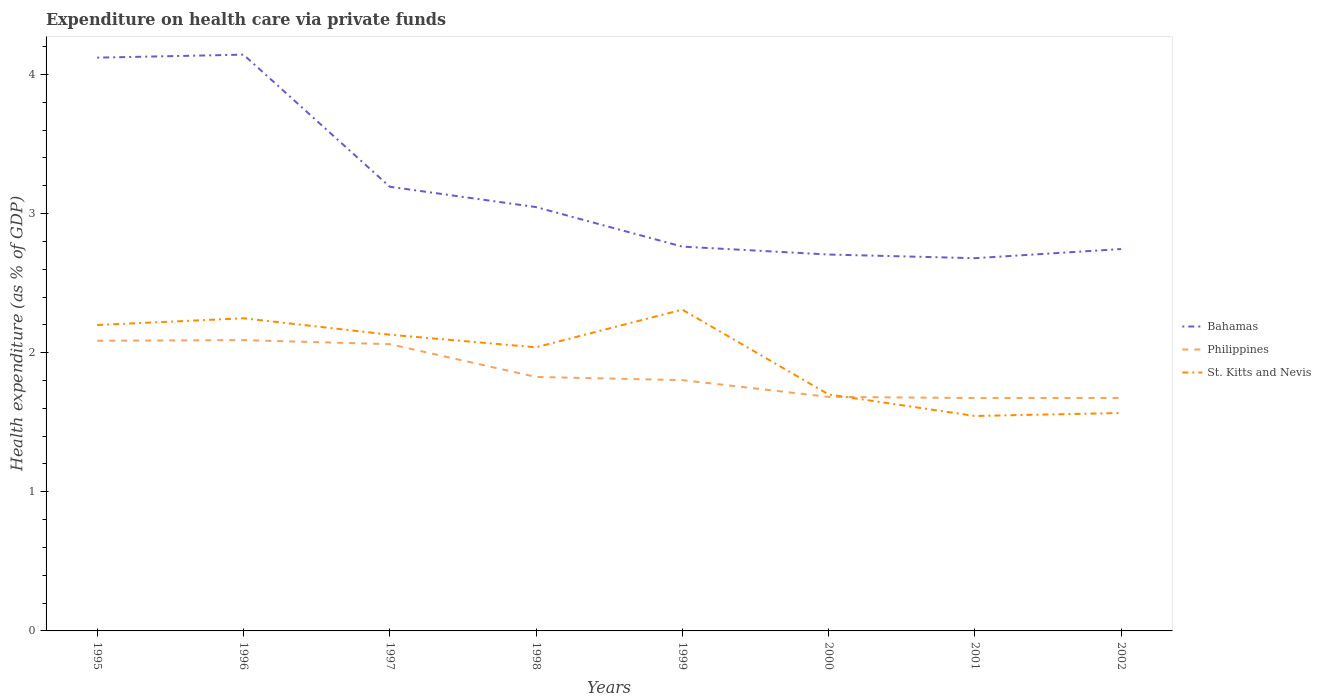How many different coloured lines are there?
Provide a short and direct response. 3. Across all years, what is the maximum expenditure made on health care in Philippines?
Provide a short and direct response. 1.67. What is the total expenditure made on health care in St. Kitts and Nevis in the graph?
Offer a very short reply. 0.43. What is the difference between the highest and the second highest expenditure made on health care in Bahamas?
Give a very brief answer. 1.46. What is the difference between the highest and the lowest expenditure made on health care in Philippines?
Ensure brevity in your answer.  3. Is the expenditure made on health care in St. Kitts and Nevis strictly greater than the expenditure made on health care in Bahamas over the years?
Offer a very short reply. Yes. How many lines are there?
Give a very brief answer. 3. What is the difference between two consecutive major ticks on the Y-axis?
Ensure brevity in your answer.  1. Are the values on the major ticks of Y-axis written in scientific E-notation?
Keep it short and to the point. No. Does the graph contain grids?
Your response must be concise. No. How are the legend labels stacked?
Your response must be concise. Vertical. What is the title of the graph?
Keep it short and to the point. Expenditure on health care via private funds. What is the label or title of the Y-axis?
Your answer should be compact. Health expenditure (as % of GDP). What is the Health expenditure (as % of GDP) in Bahamas in 1995?
Keep it short and to the point. 4.12. What is the Health expenditure (as % of GDP) in Philippines in 1995?
Provide a short and direct response. 2.09. What is the Health expenditure (as % of GDP) of St. Kitts and Nevis in 1995?
Offer a terse response. 2.2. What is the Health expenditure (as % of GDP) in Bahamas in 1996?
Your answer should be very brief. 4.14. What is the Health expenditure (as % of GDP) of Philippines in 1996?
Offer a very short reply. 2.09. What is the Health expenditure (as % of GDP) in St. Kitts and Nevis in 1996?
Offer a terse response. 2.25. What is the Health expenditure (as % of GDP) in Bahamas in 1997?
Provide a short and direct response. 3.19. What is the Health expenditure (as % of GDP) of Philippines in 1997?
Provide a short and direct response. 2.06. What is the Health expenditure (as % of GDP) in St. Kitts and Nevis in 1997?
Offer a very short reply. 2.13. What is the Health expenditure (as % of GDP) in Bahamas in 1998?
Your answer should be very brief. 3.05. What is the Health expenditure (as % of GDP) of Philippines in 1998?
Make the answer very short. 1.83. What is the Health expenditure (as % of GDP) of St. Kitts and Nevis in 1998?
Keep it short and to the point. 2.04. What is the Health expenditure (as % of GDP) in Bahamas in 1999?
Provide a short and direct response. 2.76. What is the Health expenditure (as % of GDP) of Philippines in 1999?
Offer a very short reply. 1.8. What is the Health expenditure (as % of GDP) in St. Kitts and Nevis in 1999?
Provide a succinct answer. 2.31. What is the Health expenditure (as % of GDP) in Bahamas in 2000?
Your answer should be compact. 2.71. What is the Health expenditure (as % of GDP) of Philippines in 2000?
Offer a very short reply. 1.68. What is the Health expenditure (as % of GDP) in St. Kitts and Nevis in 2000?
Provide a succinct answer. 1.7. What is the Health expenditure (as % of GDP) of Bahamas in 2001?
Give a very brief answer. 2.68. What is the Health expenditure (as % of GDP) of Philippines in 2001?
Make the answer very short. 1.67. What is the Health expenditure (as % of GDP) of St. Kitts and Nevis in 2001?
Your response must be concise. 1.55. What is the Health expenditure (as % of GDP) in Bahamas in 2002?
Keep it short and to the point. 2.75. What is the Health expenditure (as % of GDP) in Philippines in 2002?
Your response must be concise. 1.67. What is the Health expenditure (as % of GDP) in St. Kitts and Nevis in 2002?
Your response must be concise. 1.57. Across all years, what is the maximum Health expenditure (as % of GDP) in Bahamas?
Your response must be concise. 4.14. Across all years, what is the maximum Health expenditure (as % of GDP) of Philippines?
Your answer should be compact. 2.09. Across all years, what is the maximum Health expenditure (as % of GDP) of St. Kitts and Nevis?
Keep it short and to the point. 2.31. Across all years, what is the minimum Health expenditure (as % of GDP) in Bahamas?
Your answer should be compact. 2.68. Across all years, what is the minimum Health expenditure (as % of GDP) of Philippines?
Your response must be concise. 1.67. Across all years, what is the minimum Health expenditure (as % of GDP) of St. Kitts and Nevis?
Provide a short and direct response. 1.55. What is the total Health expenditure (as % of GDP) in Bahamas in the graph?
Your answer should be very brief. 25.39. What is the total Health expenditure (as % of GDP) in Philippines in the graph?
Keep it short and to the point. 14.9. What is the total Health expenditure (as % of GDP) of St. Kitts and Nevis in the graph?
Keep it short and to the point. 15.74. What is the difference between the Health expenditure (as % of GDP) of Bahamas in 1995 and that in 1996?
Your answer should be very brief. -0.02. What is the difference between the Health expenditure (as % of GDP) of Philippines in 1995 and that in 1996?
Your answer should be compact. -0. What is the difference between the Health expenditure (as % of GDP) in St. Kitts and Nevis in 1995 and that in 1996?
Your response must be concise. -0.05. What is the difference between the Health expenditure (as % of GDP) in Bahamas in 1995 and that in 1997?
Provide a short and direct response. 0.93. What is the difference between the Health expenditure (as % of GDP) in Philippines in 1995 and that in 1997?
Make the answer very short. 0.02. What is the difference between the Health expenditure (as % of GDP) of St. Kitts and Nevis in 1995 and that in 1997?
Provide a succinct answer. 0.07. What is the difference between the Health expenditure (as % of GDP) in Bahamas in 1995 and that in 1998?
Ensure brevity in your answer.  1.07. What is the difference between the Health expenditure (as % of GDP) in Philippines in 1995 and that in 1998?
Ensure brevity in your answer.  0.26. What is the difference between the Health expenditure (as % of GDP) in St. Kitts and Nevis in 1995 and that in 1998?
Provide a short and direct response. 0.16. What is the difference between the Health expenditure (as % of GDP) in Bahamas in 1995 and that in 1999?
Your answer should be compact. 1.36. What is the difference between the Health expenditure (as % of GDP) of Philippines in 1995 and that in 1999?
Provide a succinct answer. 0.28. What is the difference between the Health expenditure (as % of GDP) in St. Kitts and Nevis in 1995 and that in 1999?
Give a very brief answer. -0.11. What is the difference between the Health expenditure (as % of GDP) in Bahamas in 1995 and that in 2000?
Make the answer very short. 1.42. What is the difference between the Health expenditure (as % of GDP) of Philippines in 1995 and that in 2000?
Make the answer very short. 0.4. What is the difference between the Health expenditure (as % of GDP) in St. Kitts and Nevis in 1995 and that in 2000?
Your response must be concise. 0.5. What is the difference between the Health expenditure (as % of GDP) in Bahamas in 1995 and that in 2001?
Give a very brief answer. 1.44. What is the difference between the Health expenditure (as % of GDP) in Philippines in 1995 and that in 2001?
Your answer should be compact. 0.41. What is the difference between the Health expenditure (as % of GDP) of St. Kitts and Nevis in 1995 and that in 2001?
Give a very brief answer. 0.65. What is the difference between the Health expenditure (as % of GDP) of Bahamas in 1995 and that in 2002?
Keep it short and to the point. 1.38. What is the difference between the Health expenditure (as % of GDP) in Philippines in 1995 and that in 2002?
Provide a succinct answer. 0.41. What is the difference between the Health expenditure (as % of GDP) in St. Kitts and Nevis in 1995 and that in 2002?
Provide a short and direct response. 0.63. What is the difference between the Health expenditure (as % of GDP) of Bahamas in 1996 and that in 1997?
Ensure brevity in your answer.  0.95. What is the difference between the Health expenditure (as % of GDP) in Philippines in 1996 and that in 1997?
Your response must be concise. 0.03. What is the difference between the Health expenditure (as % of GDP) of St. Kitts and Nevis in 1996 and that in 1997?
Provide a short and direct response. 0.12. What is the difference between the Health expenditure (as % of GDP) in Bahamas in 1996 and that in 1998?
Give a very brief answer. 1.1. What is the difference between the Health expenditure (as % of GDP) of Philippines in 1996 and that in 1998?
Make the answer very short. 0.26. What is the difference between the Health expenditure (as % of GDP) of St. Kitts and Nevis in 1996 and that in 1998?
Provide a succinct answer. 0.21. What is the difference between the Health expenditure (as % of GDP) of Bahamas in 1996 and that in 1999?
Provide a succinct answer. 1.38. What is the difference between the Health expenditure (as % of GDP) of Philippines in 1996 and that in 1999?
Give a very brief answer. 0.29. What is the difference between the Health expenditure (as % of GDP) in St. Kitts and Nevis in 1996 and that in 1999?
Keep it short and to the point. -0.06. What is the difference between the Health expenditure (as % of GDP) of Bahamas in 1996 and that in 2000?
Offer a terse response. 1.44. What is the difference between the Health expenditure (as % of GDP) in Philippines in 1996 and that in 2000?
Your response must be concise. 0.41. What is the difference between the Health expenditure (as % of GDP) of St. Kitts and Nevis in 1996 and that in 2000?
Offer a terse response. 0.55. What is the difference between the Health expenditure (as % of GDP) in Bahamas in 1996 and that in 2001?
Provide a short and direct response. 1.46. What is the difference between the Health expenditure (as % of GDP) in Philippines in 1996 and that in 2001?
Offer a very short reply. 0.42. What is the difference between the Health expenditure (as % of GDP) in St. Kitts and Nevis in 1996 and that in 2001?
Make the answer very short. 0.7. What is the difference between the Health expenditure (as % of GDP) in Bahamas in 1996 and that in 2002?
Provide a short and direct response. 1.4. What is the difference between the Health expenditure (as % of GDP) of Philippines in 1996 and that in 2002?
Keep it short and to the point. 0.42. What is the difference between the Health expenditure (as % of GDP) in St. Kitts and Nevis in 1996 and that in 2002?
Ensure brevity in your answer.  0.68. What is the difference between the Health expenditure (as % of GDP) in Bahamas in 1997 and that in 1998?
Offer a terse response. 0.15. What is the difference between the Health expenditure (as % of GDP) in Philippines in 1997 and that in 1998?
Your answer should be very brief. 0.24. What is the difference between the Health expenditure (as % of GDP) in St. Kitts and Nevis in 1997 and that in 1998?
Your answer should be very brief. 0.09. What is the difference between the Health expenditure (as % of GDP) of Bahamas in 1997 and that in 1999?
Provide a short and direct response. 0.43. What is the difference between the Health expenditure (as % of GDP) in Philippines in 1997 and that in 1999?
Your answer should be compact. 0.26. What is the difference between the Health expenditure (as % of GDP) of St. Kitts and Nevis in 1997 and that in 1999?
Give a very brief answer. -0.18. What is the difference between the Health expenditure (as % of GDP) in Bahamas in 1997 and that in 2000?
Make the answer very short. 0.49. What is the difference between the Health expenditure (as % of GDP) of Philippines in 1997 and that in 2000?
Ensure brevity in your answer.  0.38. What is the difference between the Health expenditure (as % of GDP) in St. Kitts and Nevis in 1997 and that in 2000?
Make the answer very short. 0.43. What is the difference between the Health expenditure (as % of GDP) in Bahamas in 1997 and that in 2001?
Make the answer very short. 0.51. What is the difference between the Health expenditure (as % of GDP) of Philippines in 1997 and that in 2001?
Provide a succinct answer. 0.39. What is the difference between the Health expenditure (as % of GDP) in St. Kitts and Nevis in 1997 and that in 2001?
Your response must be concise. 0.58. What is the difference between the Health expenditure (as % of GDP) of Bahamas in 1997 and that in 2002?
Your answer should be compact. 0.45. What is the difference between the Health expenditure (as % of GDP) of Philippines in 1997 and that in 2002?
Provide a succinct answer. 0.39. What is the difference between the Health expenditure (as % of GDP) in St. Kitts and Nevis in 1997 and that in 2002?
Offer a very short reply. 0.56. What is the difference between the Health expenditure (as % of GDP) of Bahamas in 1998 and that in 1999?
Your answer should be very brief. 0.28. What is the difference between the Health expenditure (as % of GDP) in Philippines in 1998 and that in 1999?
Ensure brevity in your answer.  0.02. What is the difference between the Health expenditure (as % of GDP) in St. Kitts and Nevis in 1998 and that in 1999?
Your response must be concise. -0.27. What is the difference between the Health expenditure (as % of GDP) of Bahamas in 1998 and that in 2000?
Your answer should be very brief. 0.34. What is the difference between the Health expenditure (as % of GDP) in Philippines in 1998 and that in 2000?
Provide a succinct answer. 0.14. What is the difference between the Health expenditure (as % of GDP) of St. Kitts and Nevis in 1998 and that in 2000?
Your answer should be compact. 0.34. What is the difference between the Health expenditure (as % of GDP) of Bahamas in 1998 and that in 2001?
Your response must be concise. 0.37. What is the difference between the Health expenditure (as % of GDP) in Philippines in 1998 and that in 2001?
Provide a succinct answer. 0.15. What is the difference between the Health expenditure (as % of GDP) in St. Kitts and Nevis in 1998 and that in 2001?
Keep it short and to the point. 0.49. What is the difference between the Health expenditure (as % of GDP) of Bahamas in 1998 and that in 2002?
Provide a succinct answer. 0.3. What is the difference between the Health expenditure (as % of GDP) of Philippines in 1998 and that in 2002?
Ensure brevity in your answer.  0.15. What is the difference between the Health expenditure (as % of GDP) in St. Kitts and Nevis in 1998 and that in 2002?
Keep it short and to the point. 0.47. What is the difference between the Health expenditure (as % of GDP) in Bahamas in 1999 and that in 2000?
Make the answer very short. 0.06. What is the difference between the Health expenditure (as % of GDP) of Philippines in 1999 and that in 2000?
Offer a terse response. 0.12. What is the difference between the Health expenditure (as % of GDP) of St. Kitts and Nevis in 1999 and that in 2000?
Provide a short and direct response. 0.61. What is the difference between the Health expenditure (as % of GDP) in Bahamas in 1999 and that in 2001?
Offer a very short reply. 0.08. What is the difference between the Health expenditure (as % of GDP) in Philippines in 1999 and that in 2001?
Provide a succinct answer. 0.13. What is the difference between the Health expenditure (as % of GDP) of St. Kitts and Nevis in 1999 and that in 2001?
Your answer should be compact. 0.76. What is the difference between the Health expenditure (as % of GDP) in Bahamas in 1999 and that in 2002?
Your response must be concise. 0.02. What is the difference between the Health expenditure (as % of GDP) in Philippines in 1999 and that in 2002?
Make the answer very short. 0.13. What is the difference between the Health expenditure (as % of GDP) of St. Kitts and Nevis in 1999 and that in 2002?
Provide a short and direct response. 0.74. What is the difference between the Health expenditure (as % of GDP) in Bahamas in 2000 and that in 2001?
Provide a short and direct response. 0.03. What is the difference between the Health expenditure (as % of GDP) in Philippines in 2000 and that in 2001?
Provide a succinct answer. 0.01. What is the difference between the Health expenditure (as % of GDP) in St. Kitts and Nevis in 2000 and that in 2001?
Ensure brevity in your answer.  0.15. What is the difference between the Health expenditure (as % of GDP) of Bahamas in 2000 and that in 2002?
Your answer should be compact. -0.04. What is the difference between the Health expenditure (as % of GDP) of Philippines in 2000 and that in 2002?
Your answer should be very brief. 0.01. What is the difference between the Health expenditure (as % of GDP) in St. Kitts and Nevis in 2000 and that in 2002?
Offer a very short reply. 0.13. What is the difference between the Health expenditure (as % of GDP) of Bahamas in 2001 and that in 2002?
Ensure brevity in your answer.  -0.07. What is the difference between the Health expenditure (as % of GDP) in Philippines in 2001 and that in 2002?
Your response must be concise. -0. What is the difference between the Health expenditure (as % of GDP) in St. Kitts and Nevis in 2001 and that in 2002?
Make the answer very short. -0.02. What is the difference between the Health expenditure (as % of GDP) of Bahamas in 1995 and the Health expenditure (as % of GDP) of Philippines in 1996?
Make the answer very short. 2.03. What is the difference between the Health expenditure (as % of GDP) of Bahamas in 1995 and the Health expenditure (as % of GDP) of St. Kitts and Nevis in 1996?
Make the answer very short. 1.87. What is the difference between the Health expenditure (as % of GDP) in Philippines in 1995 and the Health expenditure (as % of GDP) in St. Kitts and Nevis in 1996?
Offer a terse response. -0.16. What is the difference between the Health expenditure (as % of GDP) in Bahamas in 1995 and the Health expenditure (as % of GDP) in Philippines in 1997?
Give a very brief answer. 2.06. What is the difference between the Health expenditure (as % of GDP) in Bahamas in 1995 and the Health expenditure (as % of GDP) in St. Kitts and Nevis in 1997?
Your answer should be compact. 1.99. What is the difference between the Health expenditure (as % of GDP) of Philippines in 1995 and the Health expenditure (as % of GDP) of St. Kitts and Nevis in 1997?
Offer a terse response. -0.04. What is the difference between the Health expenditure (as % of GDP) in Bahamas in 1995 and the Health expenditure (as % of GDP) in Philippines in 1998?
Keep it short and to the point. 2.3. What is the difference between the Health expenditure (as % of GDP) in Bahamas in 1995 and the Health expenditure (as % of GDP) in St. Kitts and Nevis in 1998?
Your answer should be compact. 2.08. What is the difference between the Health expenditure (as % of GDP) of Philippines in 1995 and the Health expenditure (as % of GDP) of St. Kitts and Nevis in 1998?
Offer a very short reply. 0.05. What is the difference between the Health expenditure (as % of GDP) in Bahamas in 1995 and the Health expenditure (as % of GDP) in Philippines in 1999?
Provide a short and direct response. 2.32. What is the difference between the Health expenditure (as % of GDP) in Bahamas in 1995 and the Health expenditure (as % of GDP) in St. Kitts and Nevis in 1999?
Give a very brief answer. 1.81. What is the difference between the Health expenditure (as % of GDP) of Philippines in 1995 and the Health expenditure (as % of GDP) of St. Kitts and Nevis in 1999?
Your response must be concise. -0.22. What is the difference between the Health expenditure (as % of GDP) in Bahamas in 1995 and the Health expenditure (as % of GDP) in Philippines in 2000?
Ensure brevity in your answer.  2.44. What is the difference between the Health expenditure (as % of GDP) of Bahamas in 1995 and the Health expenditure (as % of GDP) of St. Kitts and Nevis in 2000?
Your answer should be very brief. 2.42. What is the difference between the Health expenditure (as % of GDP) of Philippines in 1995 and the Health expenditure (as % of GDP) of St. Kitts and Nevis in 2000?
Your answer should be very brief. 0.39. What is the difference between the Health expenditure (as % of GDP) in Bahamas in 1995 and the Health expenditure (as % of GDP) in Philippines in 2001?
Your answer should be very brief. 2.45. What is the difference between the Health expenditure (as % of GDP) of Bahamas in 1995 and the Health expenditure (as % of GDP) of St. Kitts and Nevis in 2001?
Make the answer very short. 2.58. What is the difference between the Health expenditure (as % of GDP) of Philippines in 1995 and the Health expenditure (as % of GDP) of St. Kitts and Nevis in 2001?
Keep it short and to the point. 0.54. What is the difference between the Health expenditure (as % of GDP) in Bahamas in 1995 and the Health expenditure (as % of GDP) in Philippines in 2002?
Your answer should be very brief. 2.45. What is the difference between the Health expenditure (as % of GDP) in Bahamas in 1995 and the Health expenditure (as % of GDP) in St. Kitts and Nevis in 2002?
Your answer should be very brief. 2.55. What is the difference between the Health expenditure (as % of GDP) of Philippines in 1995 and the Health expenditure (as % of GDP) of St. Kitts and Nevis in 2002?
Offer a very short reply. 0.52. What is the difference between the Health expenditure (as % of GDP) in Bahamas in 1996 and the Health expenditure (as % of GDP) in Philippines in 1997?
Make the answer very short. 2.08. What is the difference between the Health expenditure (as % of GDP) in Bahamas in 1996 and the Health expenditure (as % of GDP) in St. Kitts and Nevis in 1997?
Ensure brevity in your answer.  2.01. What is the difference between the Health expenditure (as % of GDP) of Philippines in 1996 and the Health expenditure (as % of GDP) of St. Kitts and Nevis in 1997?
Offer a very short reply. -0.04. What is the difference between the Health expenditure (as % of GDP) of Bahamas in 1996 and the Health expenditure (as % of GDP) of Philippines in 1998?
Your answer should be very brief. 2.32. What is the difference between the Health expenditure (as % of GDP) in Bahamas in 1996 and the Health expenditure (as % of GDP) in St. Kitts and Nevis in 1998?
Offer a terse response. 2.1. What is the difference between the Health expenditure (as % of GDP) of Philippines in 1996 and the Health expenditure (as % of GDP) of St. Kitts and Nevis in 1998?
Keep it short and to the point. 0.05. What is the difference between the Health expenditure (as % of GDP) in Bahamas in 1996 and the Health expenditure (as % of GDP) in Philippines in 1999?
Keep it short and to the point. 2.34. What is the difference between the Health expenditure (as % of GDP) in Bahamas in 1996 and the Health expenditure (as % of GDP) in St. Kitts and Nevis in 1999?
Offer a very short reply. 1.83. What is the difference between the Health expenditure (as % of GDP) in Philippines in 1996 and the Health expenditure (as % of GDP) in St. Kitts and Nevis in 1999?
Your response must be concise. -0.22. What is the difference between the Health expenditure (as % of GDP) in Bahamas in 1996 and the Health expenditure (as % of GDP) in Philippines in 2000?
Offer a very short reply. 2.46. What is the difference between the Health expenditure (as % of GDP) in Bahamas in 1996 and the Health expenditure (as % of GDP) in St. Kitts and Nevis in 2000?
Offer a very short reply. 2.44. What is the difference between the Health expenditure (as % of GDP) of Philippines in 1996 and the Health expenditure (as % of GDP) of St. Kitts and Nevis in 2000?
Your response must be concise. 0.39. What is the difference between the Health expenditure (as % of GDP) in Bahamas in 1996 and the Health expenditure (as % of GDP) in Philippines in 2001?
Give a very brief answer. 2.47. What is the difference between the Health expenditure (as % of GDP) in Bahamas in 1996 and the Health expenditure (as % of GDP) in St. Kitts and Nevis in 2001?
Make the answer very short. 2.6. What is the difference between the Health expenditure (as % of GDP) in Philippines in 1996 and the Health expenditure (as % of GDP) in St. Kitts and Nevis in 2001?
Offer a terse response. 0.55. What is the difference between the Health expenditure (as % of GDP) in Bahamas in 1996 and the Health expenditure (as % of GDP) in Philippines in 2002?
Ensure brevity in your answer.  2.47. What is the difference between the Health expenditure (as % of GDP) in Bahamas in 1996 and the Health expenditure (as % of GDP) in St. Kitts and Nevis in 2002?
Offer a terse response. 2.58. What is the difference between the Health expenditure (as % of GDP) of Philippines in 1996 and the Health expenditure (as % of GDP) of St. Kitts and Nevis in 2002?
Keep it short and to the point. 0.52. What is the difference between the Health expenditure (as % of GDP) in Bahamas in 1997 and the Health expenditure (as % of GDP) in Philippines in 1998?
Give a very brief answer. 1.37. What is the difference between the Health expenditure (as % of GDP) in Bahamas in 1997 and the Health expenditure (as % of GDP) in St. Kitts and Nevis in 1998?
Offer a terse response. 1.15. What is the difference between the Health expenditure (as % of GDP) in Philippines in 1997 and the Health expenditure (as % of GDP) in St. Kitts and Nevis in 1998?
Keep it short and to the point. 0.02. What is the difference between the Health expenditure (as % of GDP) of Bahamas in 1997 and the Health expenditure (as % of GDP) of Philippines in 1999?
Your answer should be compact. 1.39. What is the difference between the Health expenditure (as % of GDP) of Bahamas in 1997 and the Health expenditure (as % of GDP) of St. Kitts and Nevis in 1999?
Provide a succinct answer. 0.88. What is the difference between the Health expenditure (as % of GDP) in Philippines in 1997 and the Health expenditure (as % of GDP) in St. Kitts and Nevis in 1999?
Keep it short and to the point. -0.25. What is the difference between the Health expenditure (as % of GDP) in Bahamas in 1997 and the Health expenditure (as % of GDP) in Philippines in 2000?
Keep it short and to the point. 1.51. What is the difference between the Health expenditure (as % of GDP) in Bahamas in 1997 and the Health expenditure (as % of GDP) in St. Kitts and Nevis in 2000?
Give a very brief answer. 1.49. What is the difference between the Health expenditure (as % of GDP) in Philippines in 1997 and the Health expenditure (as % of GDP) in St. Kitts and Nevis in 2000?
Give a very brief answer. 0.36. What is the difference between the Health expenditure (as % of GDP) in Bahamas in 1997 and the Health expenditure (as % of GDP) in Philippines in 2001?
Your response must be concise. 1.52. What is the difference between the Health expenditure (as % of GDP) in Bahamas in 1997 and the Health expenditure (as % of GDP) in St. Kitts and Nevis in 2001?
Give a very brief answer. 1.65. What is the difference between the Health expenditure (as % of GDP) of Philippines in 1997 and the Health expenditure (as % of GDP) of St. Kitts and Nevis in 2001?
Your response must be concise. 0.52. What is the difference between the Health expenditure (as % of GDP) of Bahamas in 1997 and the Health expenditure (as % of GDP) of Philippines in 2002?
Offer a terse response. 1.52. What is the difference between the Health expenditure (as % of GDP) of Bahamas in 1997 and the Health expenditure (as % of GDP) of St. Kitts and Nevis in 2002?
Ensure brevity in your answer.  1.63. What is the difference between the Health expenditure (as % of GDP) in Philippines in 1997 and the Health expenditure (as % of GDP) in St. Kitts and Nevis in 2002?
Provide a succinct answer. 0.49. What is the difference between the Health expenditure (as % of GDP) of Bahamas in 1998 and the Health expenditure (as % of GDP) of Philippines in 1999?
Give a very brief answer. 1.24. What is the difference between the Health expenditure (as % of GDP) of Bahamas in 1998 and the Health expenditure (as % of GDP) of St. Kitts and Nevis in 1999?
Your response must be concise. 0.74. What is the difference between the Health expenditure (as % of GDP) in Philippines in 1998 and the Health expenditure (as % of GDP) in St. Kitts and Nevis in 1999?
Keep it short and to the point. -0.48. What is the difference between the Health expenditure (as % of GDP) in Bahamas in 1998 and the Health expenditure (as % of GDP) in Philippines in 2000?
Your response must be concise. 1.36. What is the difference between the Health expenditure (as % of GDP) in Bahamas in 1998 and the Health expenditure (as % of GDP) in St. Kitts and Nevis in 2000?
Provide a short and direct response. 1.35. What is the difference between the Health expenditure (as % of GDP) in Philippines in 1998 and the Health expenditure (as % of GDP) in St. Kitts and Nevis in 2000?
Keep it short and to the point. 0.13. What is the difference between the Health expenditure (as % of GDP) in Bahamas in 1998 and the Health expenditure (as % of GDP) in Philippines in 2001?
Ensure brevity in your answer.  1.37. What is the difference between the Health expenditure (as % of GDP) of Bahamas in 1998 and the Health expenditure (as % of GDP) of St. Kitts and Nevis in 2001?
Your answer should be compact. 1.5. What is the difference between the Health expenditure (as % of GDP) of Philippines in 1998 and the Health expenditure (as % of GDP) of St. Kitts and Nevis in 2001?
Keep it short and to the point. 0.28. What is the difference between the Health expenditure (as % of GDP) of Bahamas in 1998 and the Health expenditure (as % of GDP) of Philippines in 2002?
Offer a very short reply. 1.37. What is the difference between the Health expenditure (as % of GDP) of Bahamas in 1998 and the Health expenditure (as % of GDP) of St. Kitts and Nevis in 2002?
Offer a terse response. 1.48. What is the difference between the Health expenditure (as % of GDP) of Philippines in 1998 and the Health expenditure (as % of GDP) of St. Kitts and Nevis in 2002?
Ensure brevity in your answer.  0.26. What is the difference between the Health expenditure (as % of GDP) in Bahamas in 1999 and the Health expenditure (as % of GDP) in Philippines in 2000?
Offer a very short reply. 1.08. What is the difference between the Health expenditure (as % of GDP) in Bahamas in 1999 and the Health expenditure (as % of GDP) in St. Kitts and Nevis in 2000?
Provide a short and direct response. 1.06. What is the difference between the Health expenditure (as % of GDP) of Philippines in 1999 and the Health expenditure (as % of GDP) of St. Kitts and Nevis in 2000?
Your response must be concise. 0.1. What is the difference between the Health expenditure (as % of GDP) of Bahamas in 1999 and the Health expenditure (as % of GDP) of Philippines in 2001?
Give a very brief answer. 1.09. What is the difference between the Health expenditure (as % of GDP) in Bahamas in 1999 and the Health expenditure (as % of GDP) in St. Kitts and Nevis in 2001?
Offer a very short reply. 1.22. What is the difference between the Health expenditure (as % of GDP) of Philippines in 1999 and the Health expenditure (as % of GDP) of St. Kitts and Nevis in 2001?
Make the answer very short. 0.26. What is the difference between the Health expenditure (as % of GDP) in Bahamas in 1999 and the Health expenditure (as % of GDP) in Philippines in 2002?
Give a very brief answer. 1.09. What is the difference between the Health expenditure (as % of GDP) of Bahamas in 1999 and the Health expenditure (as % of GDP) of St. Kitts and Nevis in 2002?
Keep it short and to the point. 1.2. What is the difference between the Health expenditure (as % of GDP) in Philippines in 1999 and the Health expenditure (as % of GDP) in St. Kitts and Nevis in 2002?
Offer a terse response. 0.24. What is the difference between the Health expenditure (as % of GDP) of Bahamas in 2000 and the Health expenditure (as % of GDP) of Philippines in 2001?
Provide a short and direct response. 1.03. What is the difference between the Health expenditure (as % of GDP) in Bahamas in 2000 and the Health expenditure (as % of GDP) in St. Kitts and Nevis in 2001?
Your response must be concise. 1.16. What is the difference between the Health expenditure (as % of GDP) of Philippines in 2000 and the Health expenditure (as % of GDP) of St. Kitts and Nevis in 2001?
Keep it short and to the point. 0.14. What is the difference between the Health expenditure (as % of GDP) of Bahamas in 2000 and the Health expenditure (as % of GDP) of Philippines in 2002?
Provide a succinct answer. 1.03. What is the difference between the Health expenditure (as % of GDP) in Bahamas in 2000 and the Health expenditure (as % of GDP) in St. Kitts and Nevis in 2002?
Provide a short and direct response. 1.14. What is the difference between the Health expenditure (as % of GDP) in Philippines in 2000 and the Health expenditure (as % of GDP) in St. Kitts and Nevis in 2002?
Keep it short and to the point. 0.12. What is the difference between the Health expenditure (as % of GDP) of Bahamas in 2001 and the Health expenditure (as % of GDP) of St. Kitts and Nevis in 2002?
Your response must be concise. 1.11. What is the difference between the Health expenditure (as % of GDP) of Philippines in 2001 and the Health expenditure (as % of GDP) of St. Kitts and Nevis in 2002?
Your response must be concise. 0.11. What is the average Health expenditure (as % of GDP) of Bahamas per year?
Offer a terse response. 3.17. What is the average Health expenditure (as % of GDP) in Philippines per year?
Make the answer very short. 1.86. What is the average Health expenditure (as % of GDP) of St. Kitts and Nevis per year?
Offer a terse response. 1.97. In the year 1995, what is the difference between the Health expenditure (as % of GDP) in Bahamas and Health expenditure (as % of GDP) in Philippines?
Offer a terse response. 2.04. In the year 1995, what is the difference between the Health expenditure (as % of GDP) of Bahamas and Health expenditure (as % of GDP) of St. Kitts and Nevis?
Offer a very short reply. 1.92. In the year 1995, what is the difference between the Health expenditure (as % of GDP) of Philippines and Health expenditure (as % of GDP) of St. Kitts and Nevis?
Provide a short and direct response. -0.11. In the year 1996, what is the difference between the Health expenditure (as % of GDP) in Bahamas and Health expenditure (as % of GDP) in Philippines?
Make the answer very short. 2.05. In the year 1996, what is the difference between the Health expenditure (as % of GDP) of Bahamas and Health expenditure (as % of GDP) of St. Kitts and Nevis?
Your response must be concise. 1.9. In the year 1996, what is the difference between the Health expenditure (as % of GDP) of Philippines and Health expenditure (as % of GDP) of St. Kitts and Nevis?
Your answer should be very brief. -0.16. In the year 1997, what is the difference between the Health expenditure (as % of GDP) of Bahamas and Health expenditure (as % of GDP) of Philippines?
Make the answer very short. 1.13. In the year 1997, what is the difference between the Health expenditure (as % of GDP) in Bahamas and Health expenditure (as % of GDP) in St. Kitts and Nevis?
Provide a short and direct response. 1.06. In the year 1997, what is the difference between the Health expenditure (as % of GDP) of Philippines and Health expenditure (as % of GDP) of St. Kitts and Nevis?
Give a very brief answer. -0.07. In the year 1998, what is the difference between the Health expenditure (as % of GDP) of Bahamas and Health expenditure (as % of GDP) of Philippines?
Make the answer very short. 1.22. In the year 1998, what is the difference between the Health expenditure (as % of GDP) in Bahamas and Health expenditure (as % of GDP) in St. Kitts and Nevis?
Your answer should be very brief. 1.01. In the year 1998, what is the difference between the Health expenditure (as % of GDP) of Philippines and Health expenditure (as % of GDP) of St. Kitts and Nevis?
Ensure brevity in your answer.  -0.21. In the year 1999, what is the difference between the Health expenditure (as % of GDP) of Bahamas and Health expenditure (as % of GDP) of Philippines?
Offer a terse response. 0.96. In the year 1999, what is the difference between the Health expenditure (as % of GDP) in Bahamas and Health expenditure (as % of GDP) in St. Kitts and Nevis?
Offer a terse response. 0.45. In the year 1999, what is the difference between the Health expenditure (as % of GDP) of Philippines and Health expenditure (as % of GDP) of St. Kitts and Nevis?
Offer a very short reply. -0.51. In the year 2000, what is the difference between the Health expenditure (as % of GDP) in Bahamas and Health expenditure (as % of GDP) in Philippines?
Your answer should be very brief. 1.02. In the year 2000, what is the difference between the Health expenditure (as % of GDP) in Philippines and Health expenditure (as % of GDP) in St. Kitts and Nevis?
Offer a very short reply. -0.02. In the year 2001, what is the difference between the Health expenditure (as % of GDP) of Bahamas and Health expenditure (as % of GDP) of St. Kitts and Nevis?
Offer a very short reply. 1.13. In the year 2001, what is the difference between the Health expenditure (as % of GDP) in Philippines and Health expenditure (as % of GDP) in St. Kitts and Nevis?
Keep it short and to the point. 0.13. In the year 2002, what is the difference between the Health expenditure (as % of GDP) in Bahamas and Health expenditure (as % of GDP) in Philippines?
Offer a terse response. 1.07. In the year 2002, what is the difference between the Health expenditure (as % of GDP) of Bahamas and Health expenditure (as % of GDP) of St. Kitts and Nevis?
Provide a short and direct response. 1.18. In the year 2002, what is the difference between the Health expenditure (as % of GDP) of Philippines and Health expenditure (as % of GDP) of St. Kitts and Nevis?
Give a very brief answer. 0.11. What is the ratio of the Health expenditure (as % of GDP) of St. Kitts and Nevis in 1995 to that in 1996?
Offer a very short reply. 0.98. What is the ratio of the Health expenditure (as % of GDP) in Bahamas in 1995 to that in 1997?
Your response must be concise. 1.29. What is the ratio of the Health expenditure (as % of GDP) of Philippines in 1995 to that in 1997?
Provide a short and direct response. 1.01. What is the ratio of the Health expenditure (as % of GDP) in St. Kitts and Nevis in 1995 to that in 1997?
Your answer should be compact. 1.03. What is the ratio of the Health expenditure (as % of GDP) of Bahamas in 1995 to that in 1998?
Offer a terse response. 1.35. What is the ratio of the Health expenditure (as % of GDP) in Philippines in 1995 to that in 1998?
Give a very brief answer. 1.14. What is the ratio of the Health expenditure (as % of GDP) of St. Kitts and Nevis in 1995 to that in 1998?
Your answer should be compact. 1.08. What is the ratio of the Health expenditure (as % of GDP) of Bahamas in 1995 to that in 1999?
Your answer should be very brief. 1.49. What is the ratio of the Health expenditure (as % of GDP) in Philippines in 1995 to that in 1999?
Provide a succinct answer. 1.16. What is the ratio of the Health expenditure (as % of GDP) of St. Kitts and Nevis in 1995 to that in 1999?
Provide a succinct answer. 0.95. What is the ratio of the Health expenditure (as % of GDP) in Bahamas in 1995 to that in 2000?
Your answer should be very brief. 1.52. What is the ratio of the Health expenditure (as % of GDP) in Philippines in 1995 to that in 2000?
Ensure brevity in your answer.  1.24. What is the ratio of the Health expenditure (as % of GDP) of St. Kitts and Nevis in 1995 to that in 2000?
Offer a very short reply. 1.29. What is the ratio of the Health expenditure (as % of GDP) in Bahamas in 1995 to that in 2001?
Your answer should be very brief. 1.54. What is the ratio of the Health expenditure (as % of GDP) of Philippines in 1995 to that in 2001?
Make the answer very short. 1.25. What is the ratio of the Health expenditure (as % of GDP) in St. Kitts and Nevis in 1995 to that in 2001?
Offer a very short reply. 1.42. What is the ratio of the Health expenditure (as % of GDP) in Bahamas in 1995 to that in 2002?
Your answer should be very brief. 1.5. What is the ratio of the Health expenditure (as % of GDP) of Philippines in 1995 to that in 2002?
Offer a terse response. 1.25. What is the ratio of the Health expenditure (as % of GDP) of St. Kitts and Nevis in 1995 to that in 2002?
Make the answer very short. 1.4. What is the ratio of the Health expenditure (as % of GDP) of Bahamas in 1996 to that in 1997?
Make the answer very short. 1.3. What is the ratio of the Health expenditure (as % of GDP) in Philippines in 1996 to that in 1997?
Offer a terse response. 1.01. What is the ratio of the Health expenditure (as % of GDP) in St. Kitts and Nevis in 1996 to that in 1997?
Give a very brief answer. 1.06. What is the ratio of the Health expenditure (as % of GDP) in Bahamas in 1996 to that in 1998?
Give a very brief answer. 1.36. What is the ratio of the Health expenditure (as % of GDP) in Philippines in 1996 to that in 1998?
Provide a short and direct response. 1.15. What is the ratio of the Health expenditure (as % of GDP) of St. Kitts and Nevis in 1996 to that in 1998?
Keep it short and to the point. 1.1. What is the ratio of the Health expenditure (as % of GDP) of Bahamas in 1996 to that in 1999?
Your answer should be compact. 1.5. What is the ratio of the Health expenditure (as % of GDP) in Philippines in 1996 to that in 1999?
Ensure brevity in your answer.  1.16. What is the ratio of the Health expenditure (as % of GDP) in St. Kitts and Nevis in 1996 to that in 1999?
Offer a very short reply. 0.97. What is the ratio of the Health expenditure (as % of GDP) of Bahamas in 1996 to that in 2000?
Offer a very short reply. 1.53. What is the ratio of the Health expenditure (as % of GDP) of Philippines in 1996 to that in 2000?
Make the answer very short. 1.24. What is the ratio of the Health expenditure (as % of GDP) of St. Kitts and Nevis in 1996 to that in 2000?
Your answer should be very brief. 1.32. What is the ratio of the Health expenditure (as % of GDP) of Bahamas in 1996 to that in 2001?
Your answer should be very brief. 1.55. What is the ratio of the Health expenditure (as % of GDP) of Philippines in 1996 to that in 2001?
Your answer should be very brief. 1.25. What is the ratio of the Health expenditure (as % of GDP) in St. Kitts and Nevis in 1996 to that in 2001?
Give a very brief answer. 1.45. What is the ratio of the Health expenditure (as % of GDP) in Bahamas in 1996 to that in 2002?
Offer a terse response. 1.51. What is the ratio of the Health expenditure (as % of GDP) of Philippines in 1996 to that in 2002?
Ensure brevity in your answer.  1.25. What is the ratio of the Health expenditure (as % of GDP) in St. Kitts and Nevis in 1996 to that in 2002?
Your answer should be compact. 1.43. What is the ratio of the Health expenditure (as % of GDP) of Bahamas in 1997 to that in 1998?
Provide a succinct answer. 1.05. What is the ratio of the Health expenditure (as % of GDP) of Philippines in 1997 to that in 1998?
Give a very brief answer. 1.13. What is the ratio of the Health expenditure (as % of GDP) of St. Kitts and Nevis in 1997 to that in 1998?
Make the answer very short. 1.04. What is the ratio of the Health expenditure (as % of GDP) of Bahamas in 1997 to that in 1999?
Offer a terse response. 1.16. What is the ratio of the Health expenditure (as % of GDP) of Philippines in 1997 to that in 1999?
Offer a terse response. 1.14. What is the ratio of the Health expenditure (as % of GDP) in St. Kitts and Nevis in 1997 to that in 1999?
Your response must be concise. 0.92. What is the ratio of the Health expenditure (as % of GDP) of Bahamas in 1997 to that in 2000?
Your answer should be compact. 1.18. What is the ratio of the Health expenditure (as % of GDP) in Philippines in 1997 to that in 2000?
Give a very brief answer. 1.23. What is the ratio of the Health expenditure (as % of GDP) of St. Kitts and Nevis in 1997 to that in 2000?
Make the answer very short. 1.25. What is the ratio of the Health expenditure (as % of GDP) in Bahamas in 1997 to that in 2001?
Give a very brief answer. 1.19. What is the ratio of the Health expenditure (as % of GDP) in Philippines in 1997 to that in 2001?
Provide a short and direct response. 1.23. What is the ratio of the Health expenditure (as % of GDP) in St. Kitts and Nevis in 1997 to that in 2001?
Offer a terse response. 1.38. What is the ratio of the Health expenditure (as % of GDP) in Bahamas in 1997 to that in 2002?
Ensure brevity in your answer.  1.16. What is the ratio of the Health expenditure (as % of GDP) in Philippines in 1997 to that in 2002?
Make the answer very short. 1.23. What is the ratio of the Health expenditure (as % of GDP) of St. Kitts and Nevis in 1997 to that in 2002?
Provide a succinct answer. 1.36. What is the ratio of the Health expenditure (as % of GDP) of Bahamas in 1998 to that in 1999?
Make the answer very short. 1.1. What is the ratio of the Health expenditure (as % of GDP) of Philippines in 1998 to that in 1999?
Your response must be concise. 1.01. What is the ratio of the Health expenditure (as % of GDP) in St. Kitts and Nevis in 1998 to that in 1999?
Provide a succinct answer. 0.88. What is the ratio of the Health expenditure (as % of GDP) in Bahamas in 1998 to that in 2000?
Ensure brevity in your answer.  1.13. What is the ratio of the Health expenditure (as % of GDP) in Philippines in 1998 to that in 2000?
Make the answer very short. 1.09. What is the ratio of the Health expenditure (as % of GDP) in St. Kitts and Nevis in 1998 to that in 2000?
Offer a terse response. 1.2. What is the ratio of the Health expenditure (as % of GDP) in Bahamas in 1998 to that in 2001?
Your response must be concise. 1.14. What is the ratio of the Health expenditure (as % of GDP) in Philippines in 1998 to that in 2001?
Give a very brief answer. 1.09. What is the ratio of the Health expenditure (as % of GDP) of St. Kitts and Nevis in 1998 to that in 2001?
Provide a short and direct response. 1.32. What is the ratio of the Health expenditure (as % of GDP) of Bahamas in 1998 to that in 2002?
Offer a terse response. 1.11. What is the ratio of the Health expenditure (as % of GDP) in Philippines in 1998 to that in 2002?
Your answer should be very brief. 1.09. What is the ratio of the Health expenditure (as % of GDP) of St. Kitts and Nevis in 1998 to that in 2002?
Ensure brevity in your answer.  1.3. What is the ratio of the Health expenditure (as % of GDP) in Philippines in 1999 to that in 2000?
Your answer should be compact. 1.07. What is the ratio of the Health expenditure (as % of GDP) of St. Kitts and Nevis in 1999 to that in 2000?
Offer a terse response. 1.36. What is the ratio of the Health expenditure (as % of GDP) in Bahamas in 1999 to that in 2001?
Provide a succinct answer. 1.03. What is the ratio of the Health expenditure (as % of GDP) of Philippines in 1999 to that in 2001?
Make the answer very short. 1.08. What is the ratio of the Health expenditure (as % of GDP) of St. Kitts and Nevis in 1999 to that in 2001?
Provide a short and direct response. 1.49. What is the ratio of the Health expenditure (as % of GDP) of Bahamas in 1999 to that in 2002?
Offer a very short reply. 1.01. What is the ratio of the Health expenditure (as % of GDP) in Philippines in 1999 to that in 2002?
Offer a terse response. 1.08. What is the ratio of the Health expenditure (as % of GDP) in St. Kitts and Nevis in 1999 to that in 2002?
Offer a very short reply. 1.47. What is the ratio of the Health expenditure (as % of GDP) in Bahamas in 2000 to that in 2001?
Ensure brevity in your answer.  1.01. What is the ratio of the Health expenditure (as % of GDP) in St. Kitts and Nevis in 2000 to that in 2001?
Make the answer very short. 1.1. What is the ratio of the Health expenditure (as % of GDP) in Bahamas in 2000 to that in 2002?
Your answer should be compact. 0.99. What is the ratio of the Health expenditure (as % of GDP) in Philippines in 2000 to that in 2002?
Your answer should be compact. 1. What is the ratio of the Health expenditure (as % of GDP) of St. Kitts and Nevis in 2000 to that in 2002?
Give a very brief answer. 1.09. What is the ratio of the Health expenditure (as % of GDP) of Bahamas in 2001 to that in 2002?
Provide a succinct answer. 0.98. What is the ratio of the Health expenditure (as % of GDP) of Philippines in 2001 to that in 2002?
Ensure brevity in your answer.  1. What is the ratio of the Health expenditure (as % of GDP) in St. Kitts and Nevis in 2001 to that in 2002?
Offer a very short reply. 0.99. What is the difference between the highest and the second highest Health expenditure (as % of GDP) of Bahamas?
Give a very brief answer. 0.02. What is the difference between the highest and the second highest Health expenditure (as % of GDP) of Philippines?
Give a very brief answer. 0. What is the difference between the highest and the second highest Health expenditure (as % of GDP) in St. Kitts and Nevis?
Give a very brief answer. 0.06. What is the difference between the highest and the lowest Health expenditure (as % of GDP) of Bahamas?
Give a very brief answer. 1.46. What is the difference between the highest and the lowest Health expenditure (as % of GDP) in Philippines?
Your response must be concise. 0.42. What is the difference between the highest and the lowest Health expenditure (as % of GDP) in St. Kitts and Nevis?
Your answer should be compact. 0.76. 